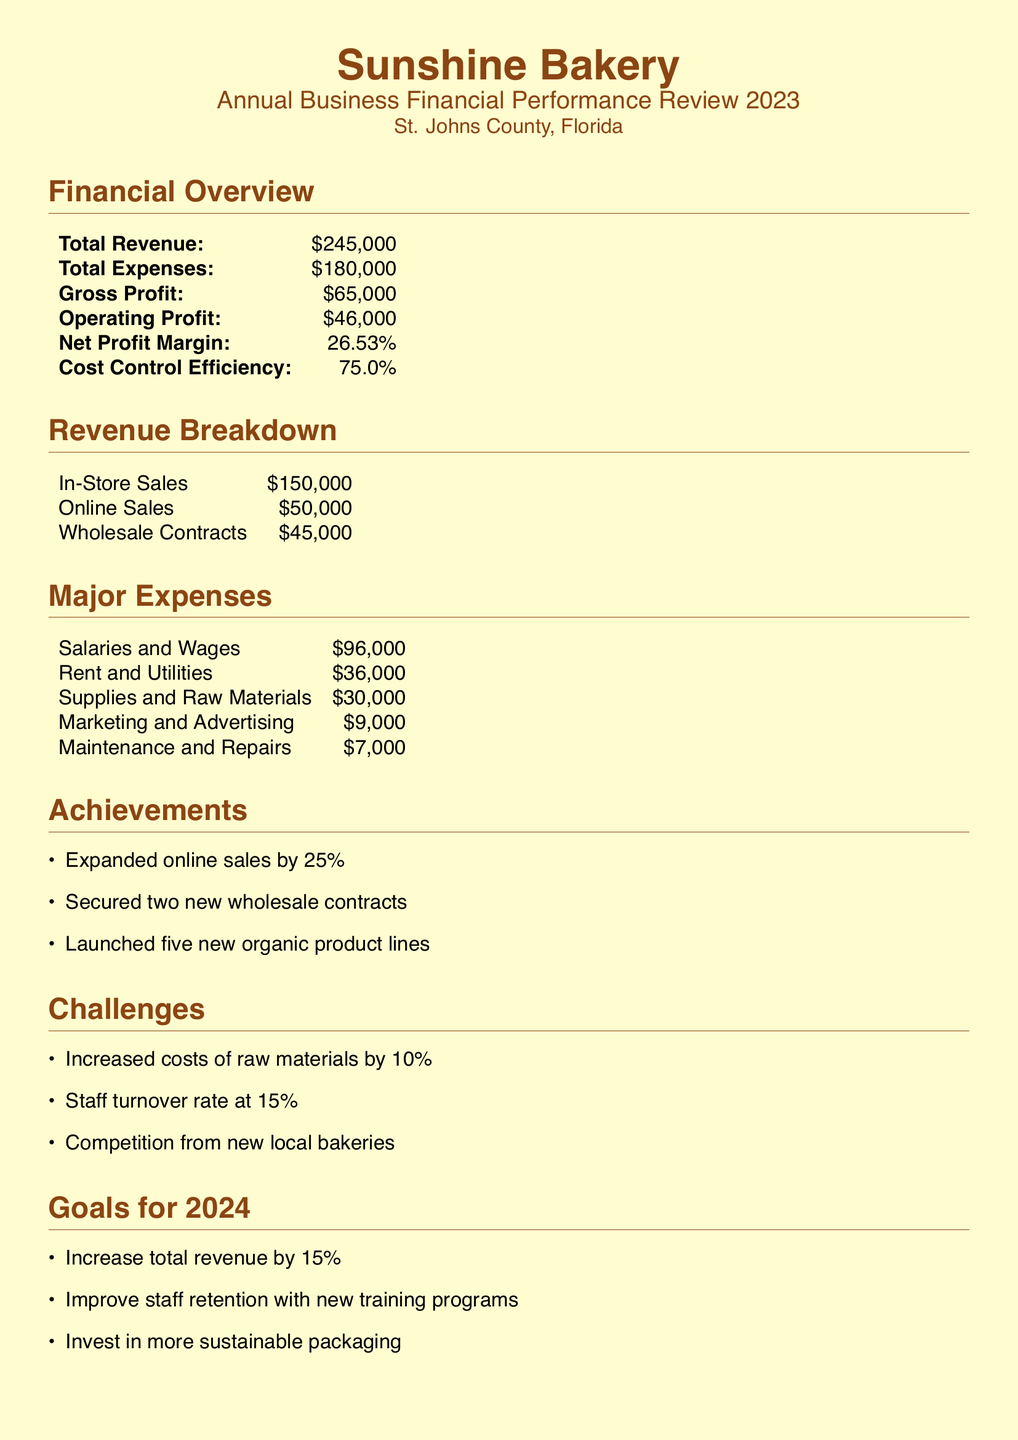What is the total revenue? The total revenue is listed in the document as the overall income generated by the bakery in 2023.
Answer: $245,000 What is the net profit margin? The net profit margin is calculated as net profit divided by total revenue and is provided as a percentage in the document.
Answer: 26.53% How much did Sunshine Bakery earn from online sales? The income specifically from online sales is a part of the revenue breakdown shown in the document.
Answer: $50,000 What are the total expenses? The total expenses amount reflects the overall costs incurred by the bakery during the year as listed in the document.
Answer: $180,000 What was the increase in online sales? The document states the percentage increase in online sales compared to the previous year, reflecting growth in that area.
Answer: 25% What was the cost control efficiency? The cost control efficiency indicates how well the business managed its expenses relative to its revenue and is stated in the financial overview.
Answer: 75.0% How many new wholesale contracts were secured? The number of new wholesale contracts achieved by the bakery is mentioned under the achievements section in the document.
Answer: Two What is the staff turnover rate? The staff turnover rate is mentioned under the challenges, highlighting a workforce issue faced by the bakery.
Answer: 15% What goal is set for total revenue in 2024? The document outlines specific goals for the next year, particularly about revenue growth, which is quantified.
Answer: 15% 